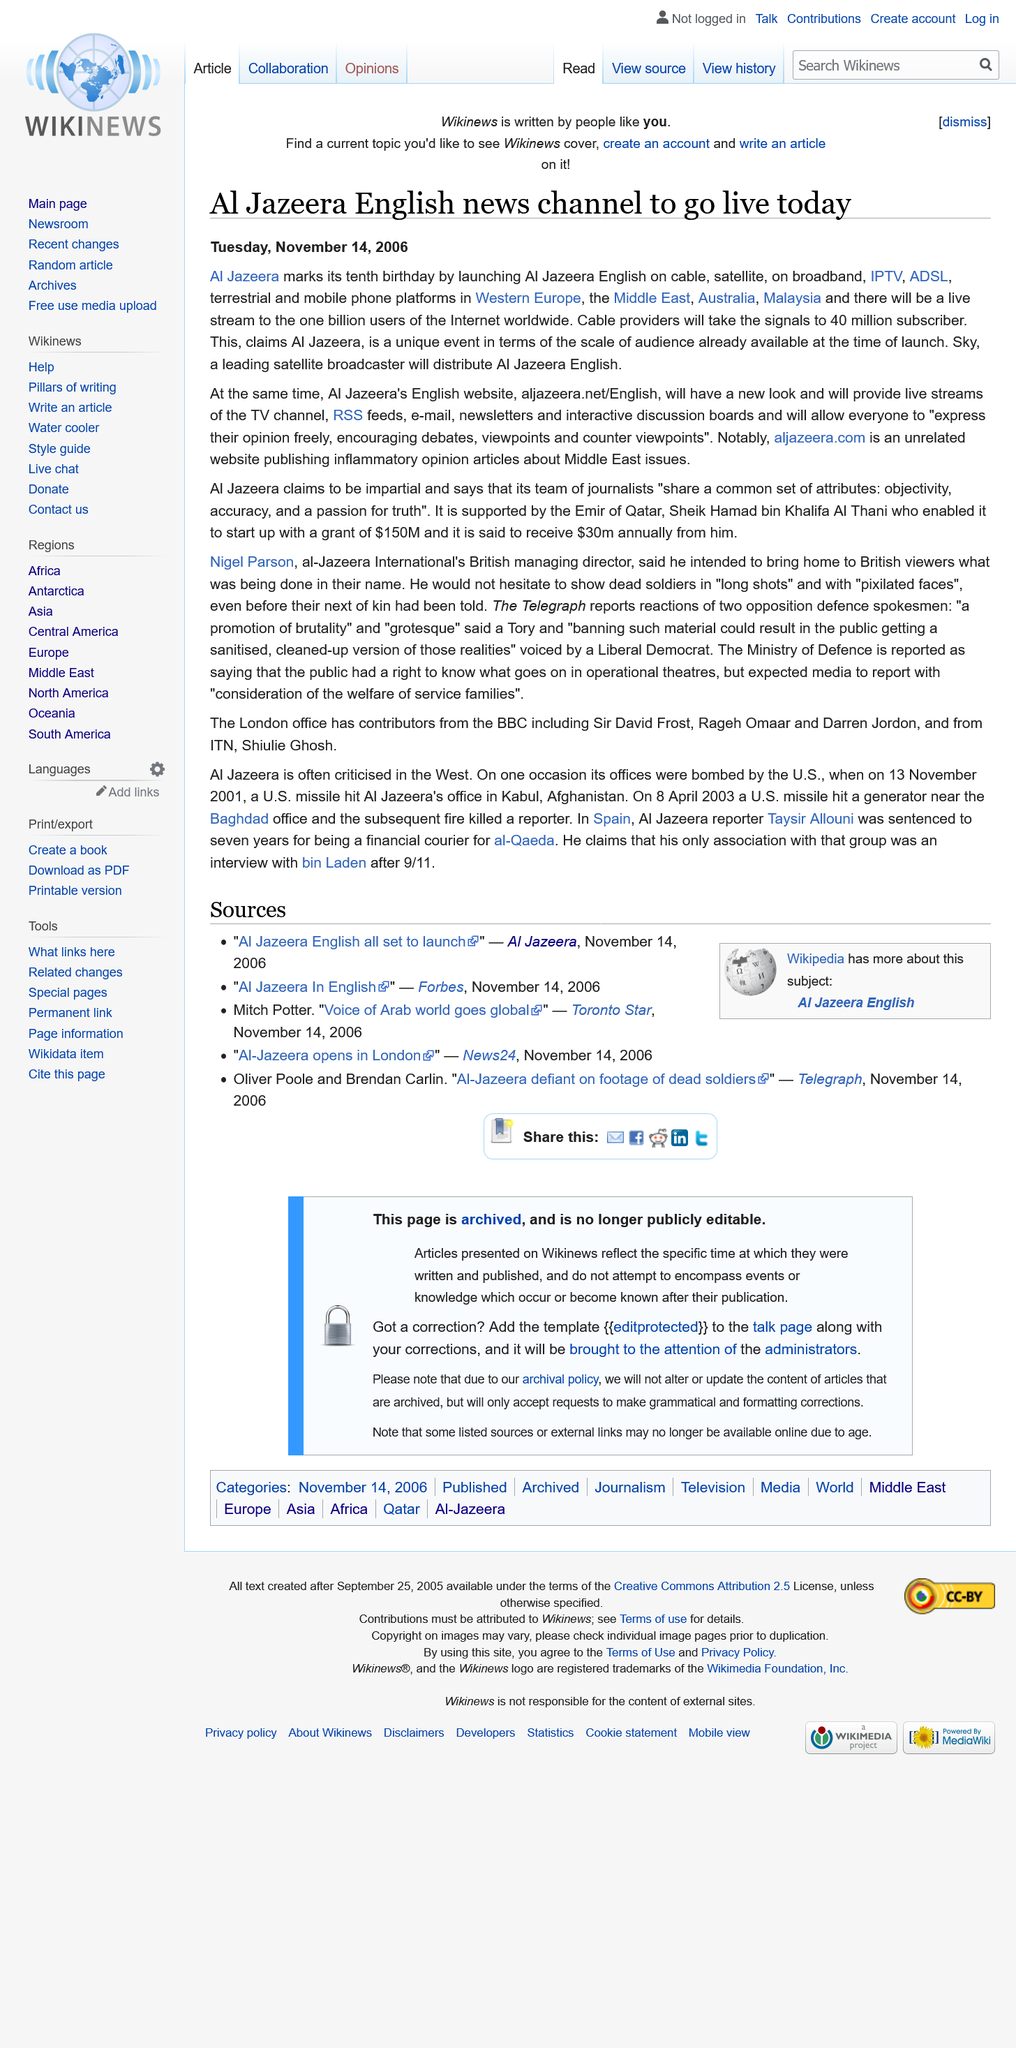List a handful of essential elements in this visual. Al Jazeera is celebrating its 10th birthday. Cable providers will take signals to approximately 40 million subscribers. The article was published on Tuesday, November 14, 2006. 